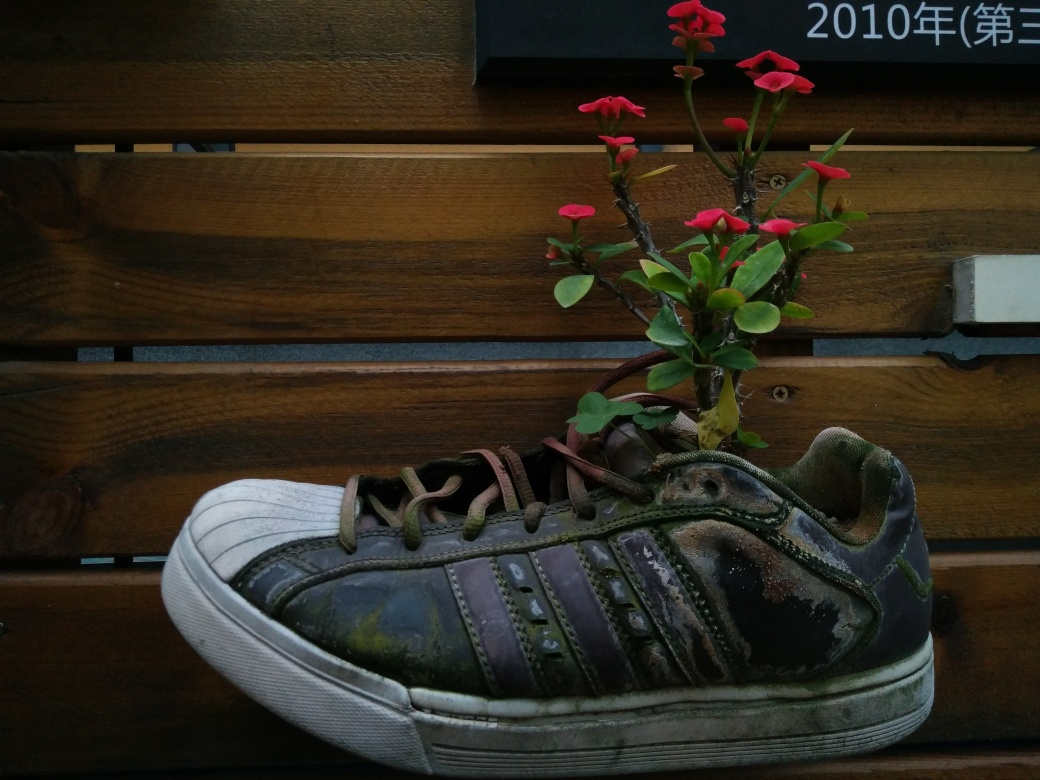How does the image evoke a sense of age or history? The weathered texture and scuff marks on the sneaker suggest it has been well-used and has aged over time. Additionally, the contrast between the vibrant, fresh plant and the old shoe highlights the passage of time and creates a poignant juxtaposition between growth and decay. 